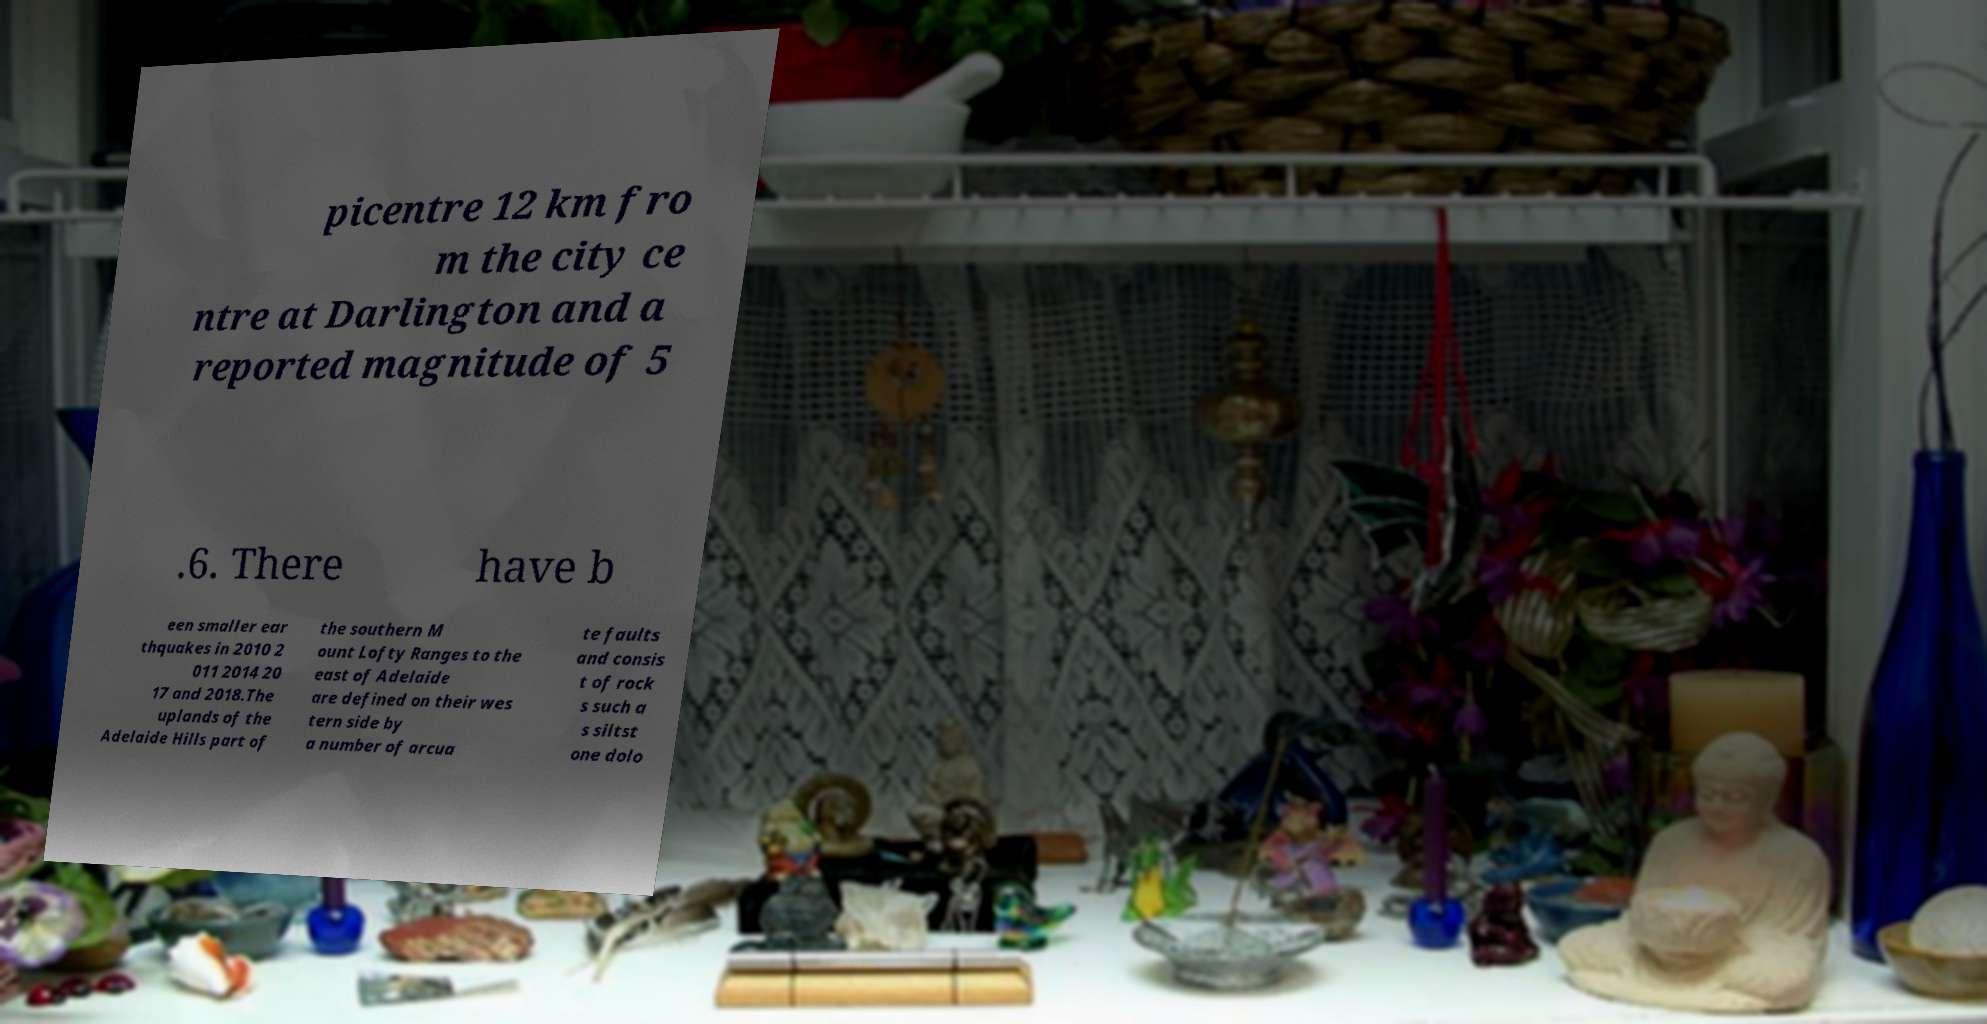What messages or text are displayed in this image? I need them in a readable, typed format. picentre 12 km fro m the city ce ntre at Darlington and a reported magnitude of 5 .6. There have b een smaller ear thquakes in 2010 2 011 2014 20 17 and 2018.The uplands of the Adelaide Hills part of the southern M ount Lofty Ranges to the east of Adelaide are defined on their wes tern side by a number of arcua te faults and consis t of rock s such a s siltst one dolo 